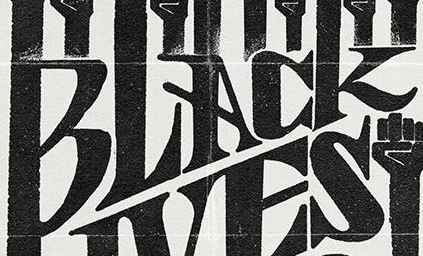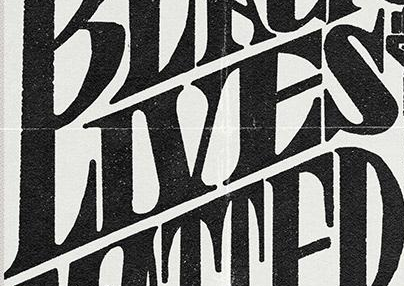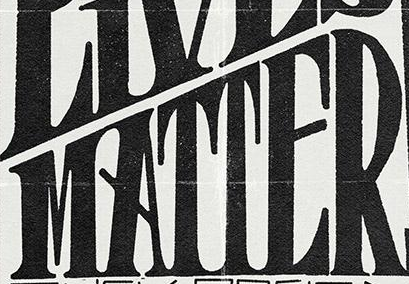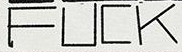Transcribe the words shown in these images in order, separated by a semicolon. BLACK; LIVES; MATTER; FUCK 